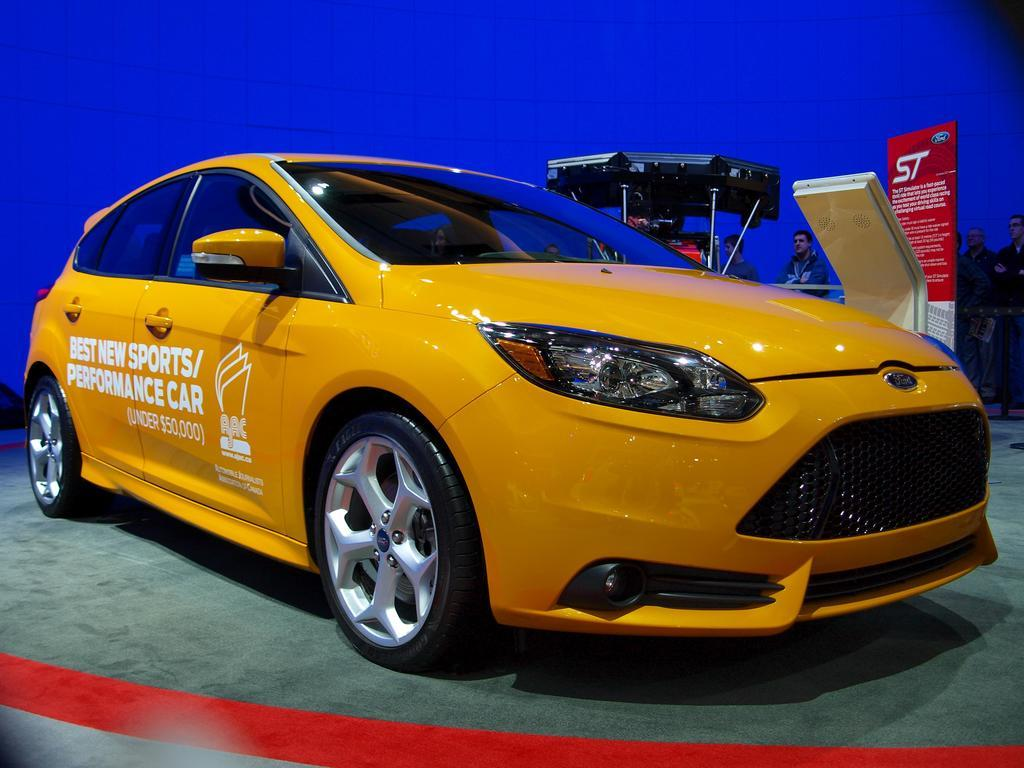What color is the background of the image? The background of the image is blue. Where are the people located in the image? The people are on the right side of the image. What can be seen in the image besides the people? There is a board and objects on the right side of the image, as well as a car on the floor. What type of art is being created on the board in the image? There is no art being created on the board in the image; it is not mentioned in the provided facts. What kind of meat is being served on the board in the image? There is no meat present in the image, and the board does not appear to be used for serving food. 